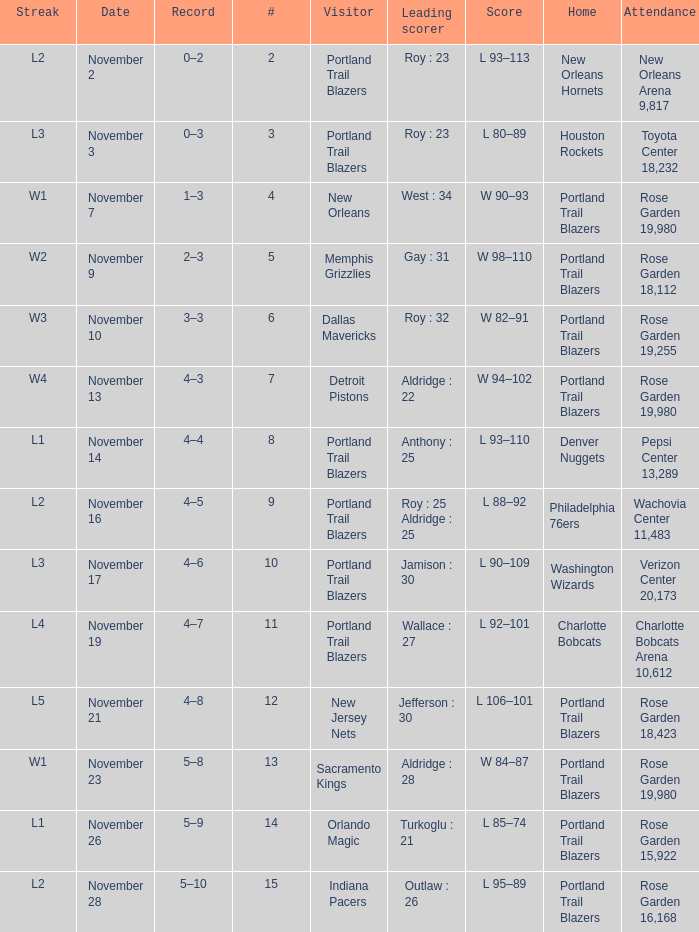 what's the score where record is 0–2 L 93–113. 